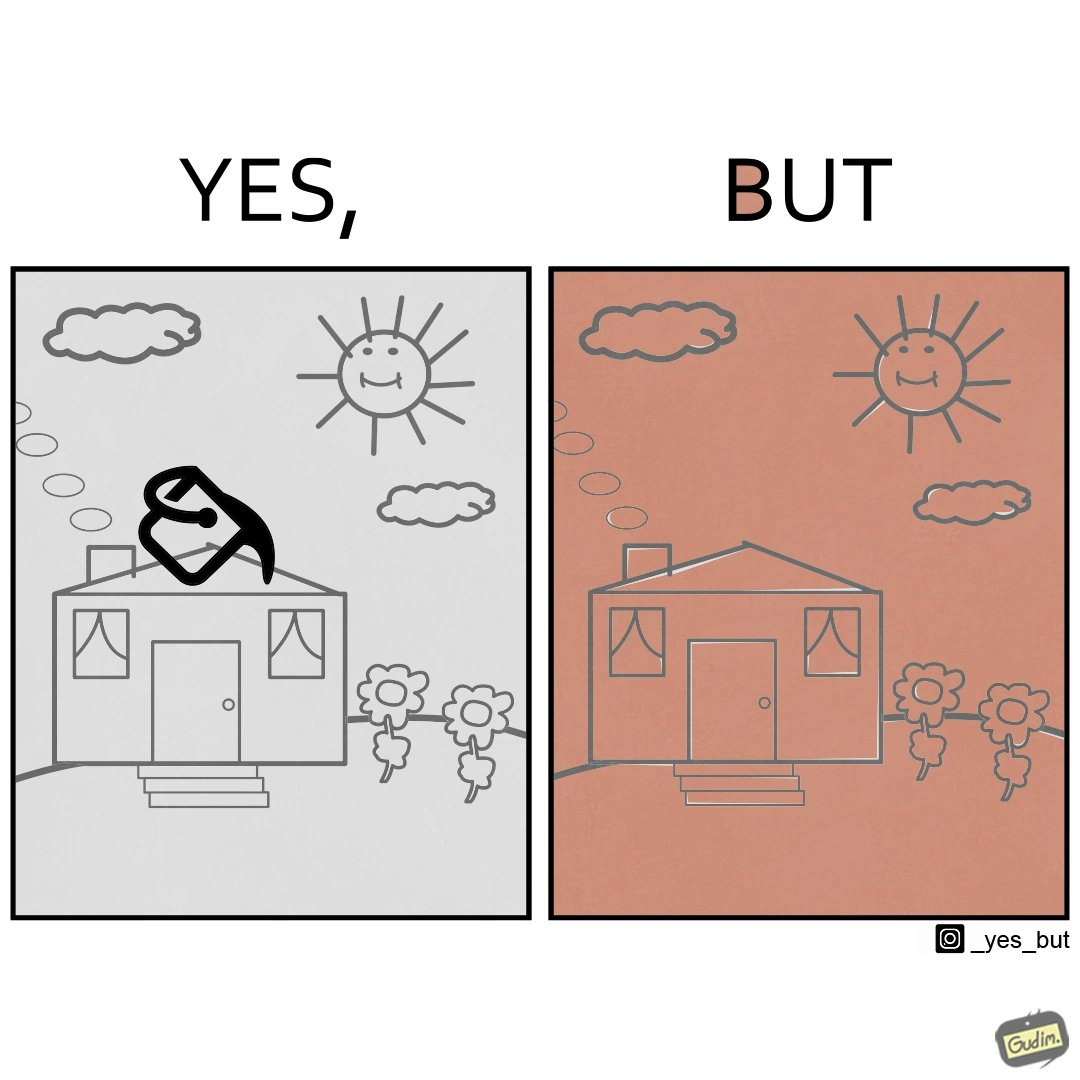Describe what you see in this image. The image is funny and showing a common problem with microsoft paint like applications where even a slight openings in the shapes causes entire drawing to be filled with the same color when using the fill color option. In this case, the person using the application intended to color only the ceiling of the house to brick red but ended up coloring the whole drawing with the brick red color. 